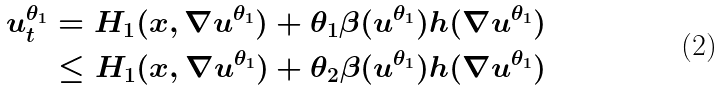<formula> <loc_0><loc_0><loc_500><loc_500>u ^ { \theta _ { 1 } } _ { t } & = H _ { 1 } ( x , \nabla u ^ { \theta _ { 1 } } ) + \theta _ { 1 } \beta ( u ^ { \theta _ { 1 } } ) h ( \nabla u ^ { \theta _ { 1 } } ) \\ & \leq H _ { 1 } ( x , \nabla u ^ { \theta _ { 1 } } ) + \theta _ { 2 } \beta ( u ^ { \theta _ { 1 } } ) h ( \nabla u ^ { \theta _ { 1 } } )</formula> 